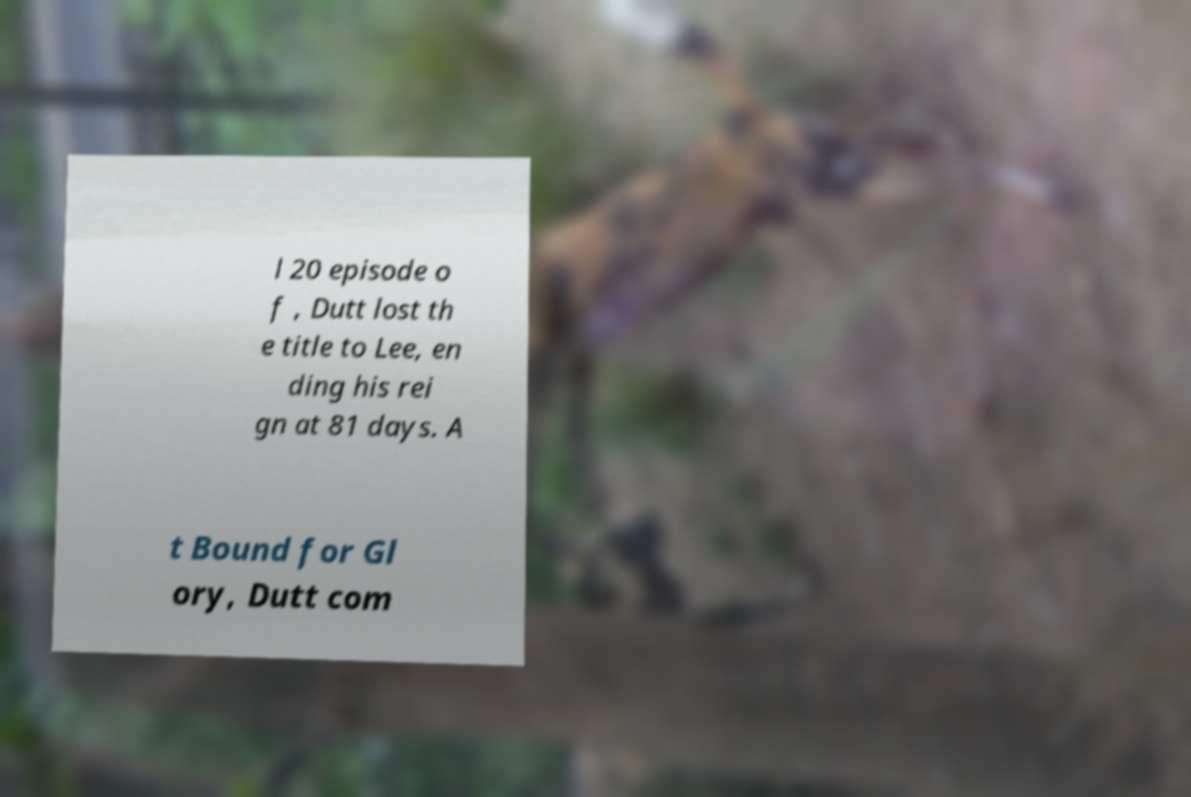I need the written content from this picture converted into text. Can you do that? l 20 episode o f , Dutt lost th e title to Lee, en ding his rei gn at 81 days. A t Bound for Gl ory, Dutt com 